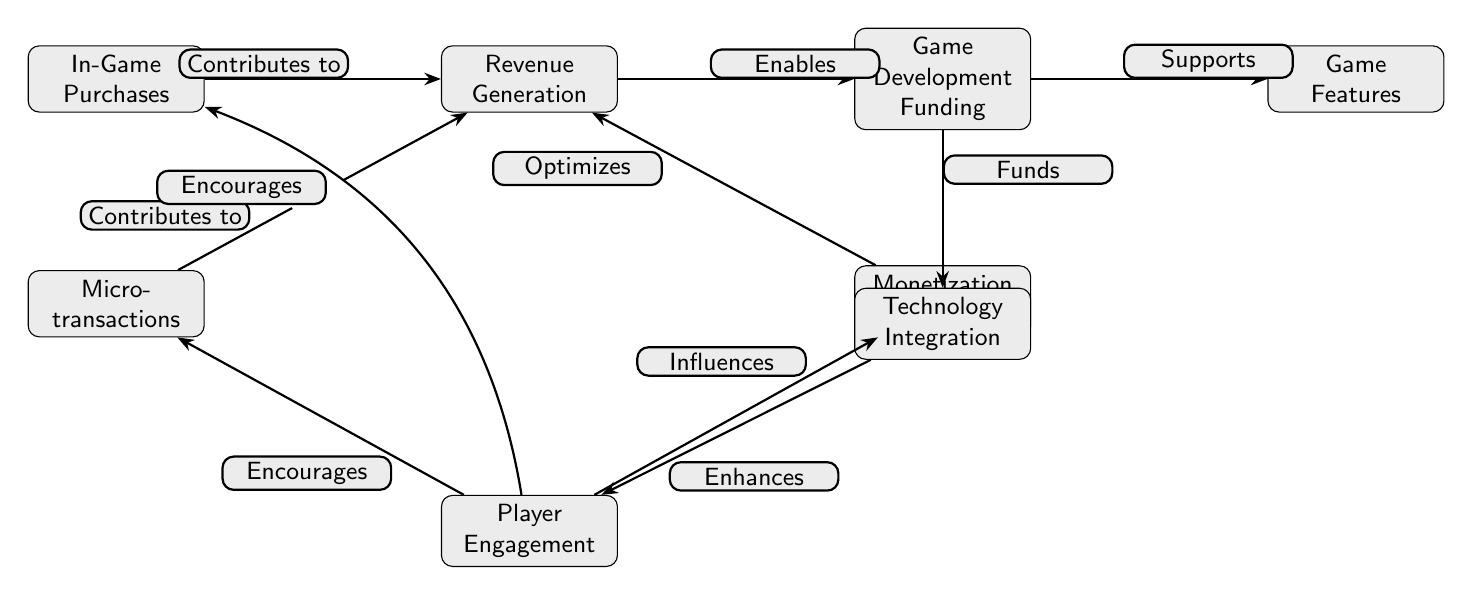What are the two primary sources of revenue in the diagram? The diagram clearly indicates that "In-Game Purchases" and "Micro-transactions" are the two nodes directly contributing to "Revenue Generation."
Answer: In-Game Purchases, Micro-transactions How many nodes are present in the diagram? By counting all the distinct entities or concepts presented within the diagram, there are a total of eight nodes.
Answer: 8 What action does "Revenue Generation" enable? The diagram describes that "Revenue Generation" directly enables "Game Development Funding," showing a clear flow from one to the other.
Answer: Game Development Funding What does "Player Engagement" encourage according to the diagram? The edges indicate that "Player Engagement" encourages both "In-Game Purchases" and "Micro-transactions," signifying a dual influence.
Answer: In-Game Purchases, Micro-transactions Which node is supported by "Game Development Funding"? According to the diagram, "Game Development Funding" supports "Game Features," indicating a direct relationship between the two nodes.
Answer: Game Features What influences the "Monetization Strategies"? The diagram shows that "Player Engagement" influences "Monetization Strategies," highlighting that player interaction affects how monetization is implemented in games.
Answer: Player Engagement How many edges are there in the diagram? By examining the connections between the nodes, we can identify a total of eight edges that represent relationships between different elements.
Answer: 8 What enhances "Player Engagement"? It is clear from the diagram that "Technology Integration" enhances "Player Engagement," indicating that tech plays a role in keeping players interested.
Answer: Technology Integration What is the relationship between "Game Development Funding" and "Technology Integration"? The diagram illustrates that "Game Development Funding" funds "Technology Integration," showing a financial connection that helps develop technology for games.
Answer: Funds 